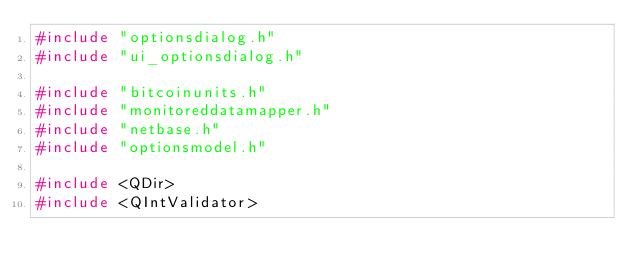<code> <loc_0><loc_0><loc_500><loc_500><_C++_>#include "optionsdialog.h"
#include "ui_optionsdialog.h"

#include "bitcoinunits.h"
#include "monitoreddatamapper.h"
#include "netbase.h"
#include "optionsmodel.h"

#include <QDir>
#include <QIntValidator></code> 